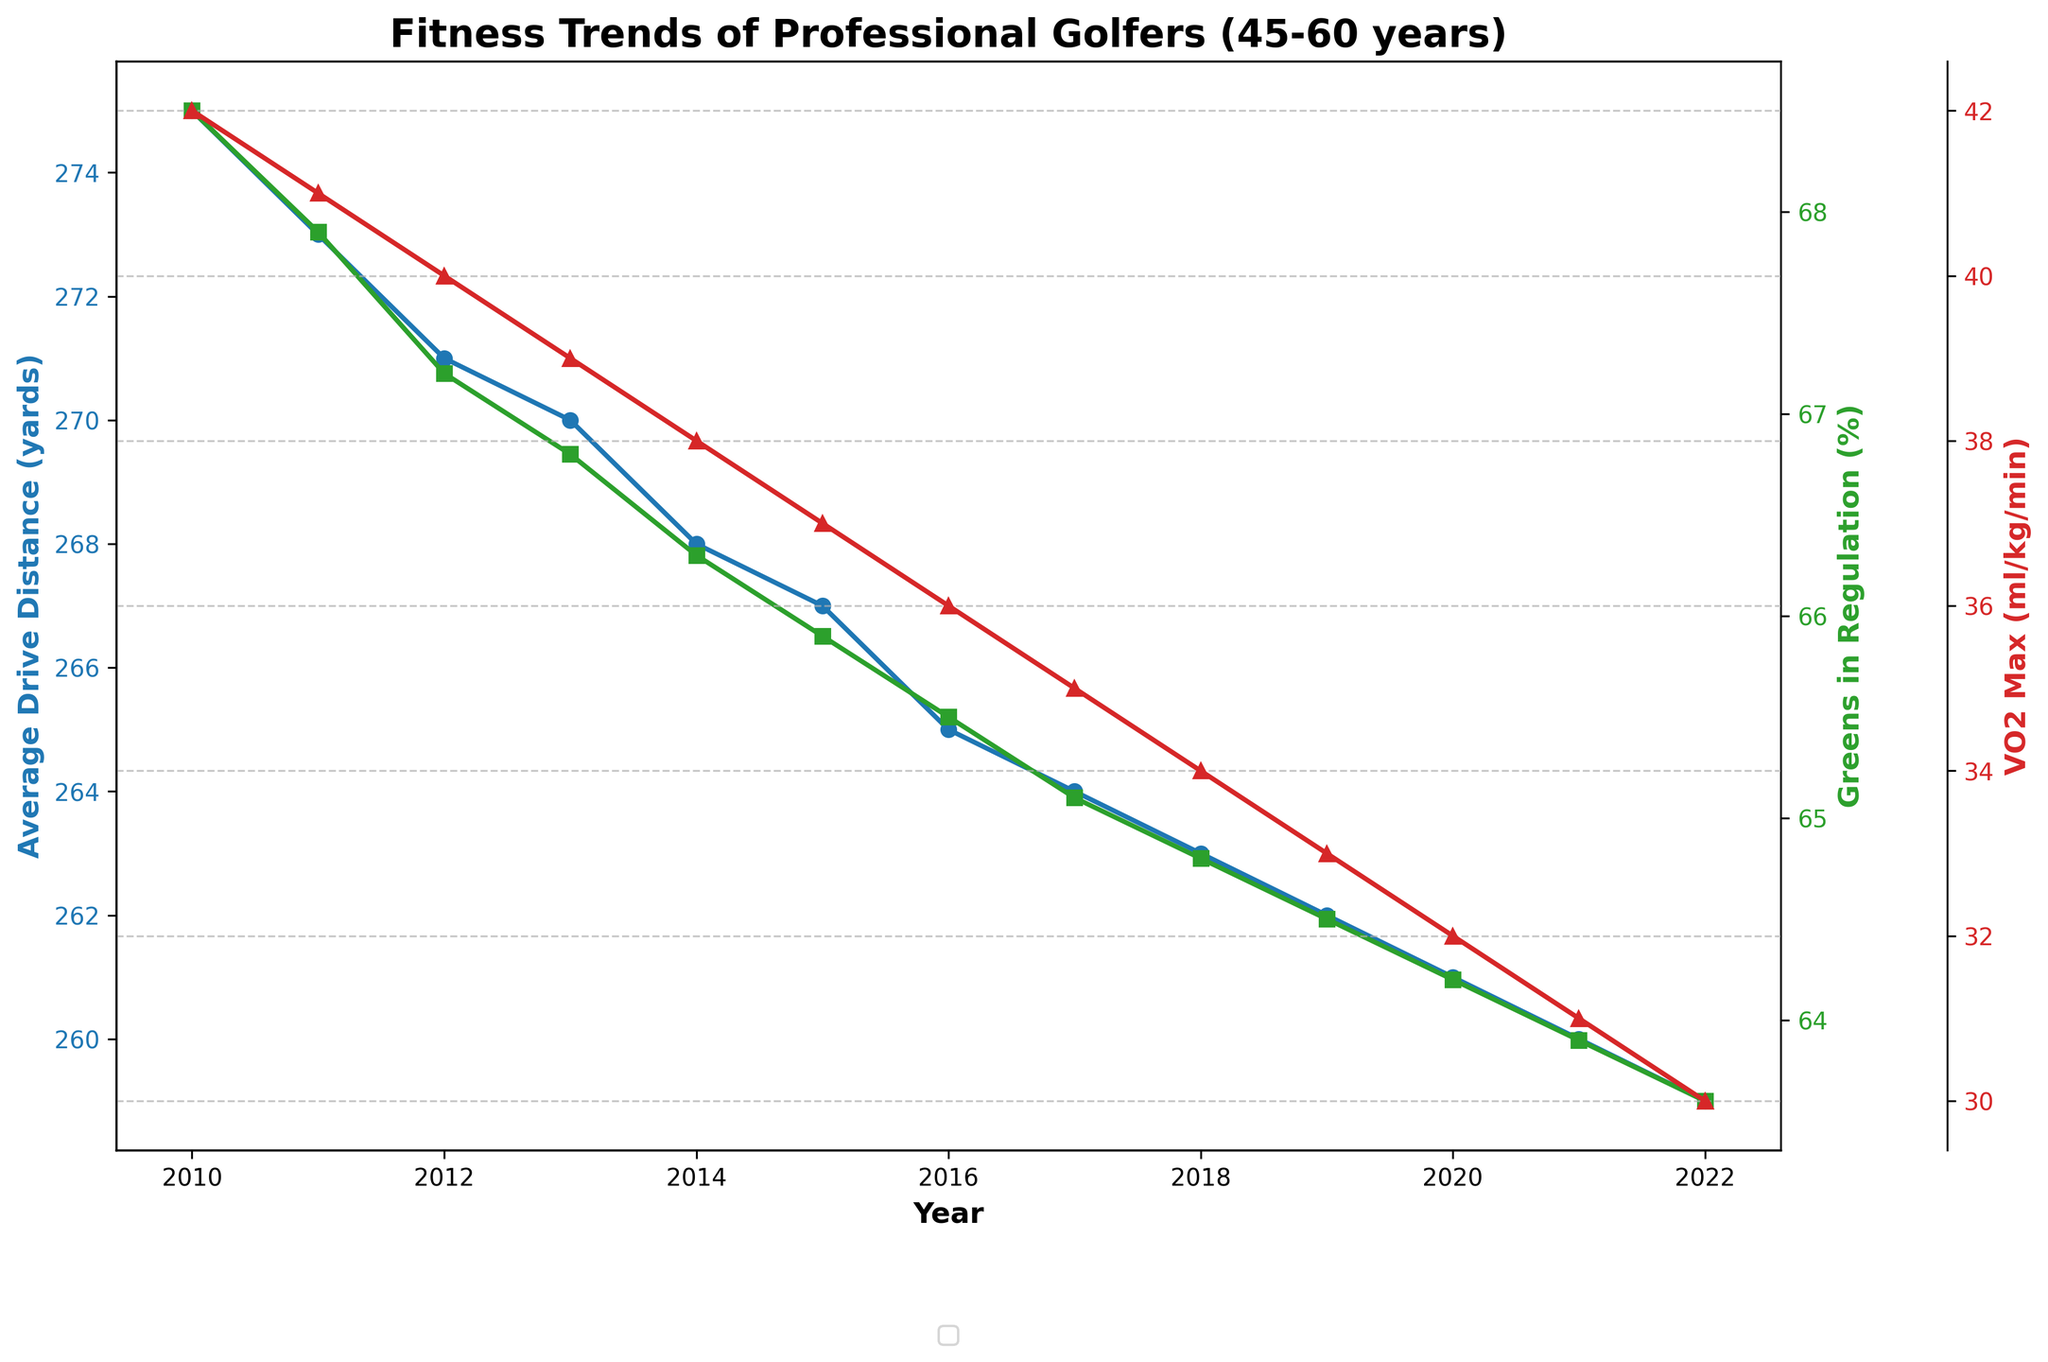What is the trend of Average Drive Distance over the years? The figure shows a line plot for Average Drive Distance in blue, which has a consistent downward trend from 2010 to 2022. This can be seen by the decreasing position of the data points year over year.
Answer: Decreasing How does the trend of Greens in Regulation compare to the trend of Average Drive Distance? The Greens in Regulation percentage, plotted in green, also shows a generally decreasing trend similar to the Average Drive Distance. Both metrics decline over the years, suggesting a possible correlation.
Answer: Similar decreasing trend Which year has the highest VO2 Max, and what is its value? The red line plot for VO2 Max peaks at 42 ml/kg/min in the year 2010. This is the highest value according to the plotted trend.
Answer: 2010, 42 ml/kg/min Compare the Greens in Regulation (%) for the years 2010 and 2022. Compare the green data points for the two years: it was 68.5% in 2010 and decreased to 63.6% by 2022.
Answer: 68.5% in 2010 and 63.6% in 2022 What is the difference in Average Drive Distance between the years 2015 and 2020? Refer to the blue line: in 2015, the Average Drive Distance was 267 yards and in 2020, it was 261 yards. The difference is 267 - 261 = 6 yards.
Answer: 6 yards What is the average VO2 Max over the years 2018 to 2022? VO2 Max values for the years 2018, 2019, 2020, 2021, and 2022 are 34, 33, 32, 31, and 30 ml/kg/min respectively. Sum them up: 34 + 33 + 32 + 31 + 30 = 160. The average is 160 / 5 = 32 ml/kg/min.
Answer: 32 ml/kg/min In which year are the three metrics (Average Drive Distance, Greens in Regulation, VO2 Max) all at or near their minimum values? By examining the lines, all three metrics are at or near their lowest points in 2022.
Answer: 2022 What is the total decline in Greens in Regulation percentage from 2010 to 2022? In 2010, the Greens in Regulation was 68.5%, and in 2022, it was 63.6%. The total decline is 68.5% - 63.6% = 4.9%.
Answer: 4.9% Between which consecutive years does the Average Drive Distance experience the smallest decline? By comparing the blue line’s slope between years, the smallest decline appears between 2011 (273 yards) and 2012 (271 yards), which is a difference of 2 yards.
Answer: 2011 to 2012 How is the VO2 Max trend visually distinct from the Average Drive Distance trend? The VO2 Max (red line) shows a steeper and more consistent decline compared to the Average Drive Distance (blue line), indicating a sharper drop in VO2 Max over the years.
Answer: Steeper decline 